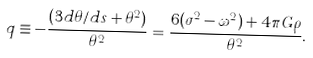<formula> <loc_0><loc_0><loc_500><loc_500>q \equiv - \frac { ( 3 d \theta / d s + \theta ^ { 2 } ) } { \theta ^ { 2 } } = \frac { 6 ( \sigma ^ { 2 } - \omega ^ { 2 } ) + 4 \pi G \rho } { \theta ^ { 2 } } .</formula> 